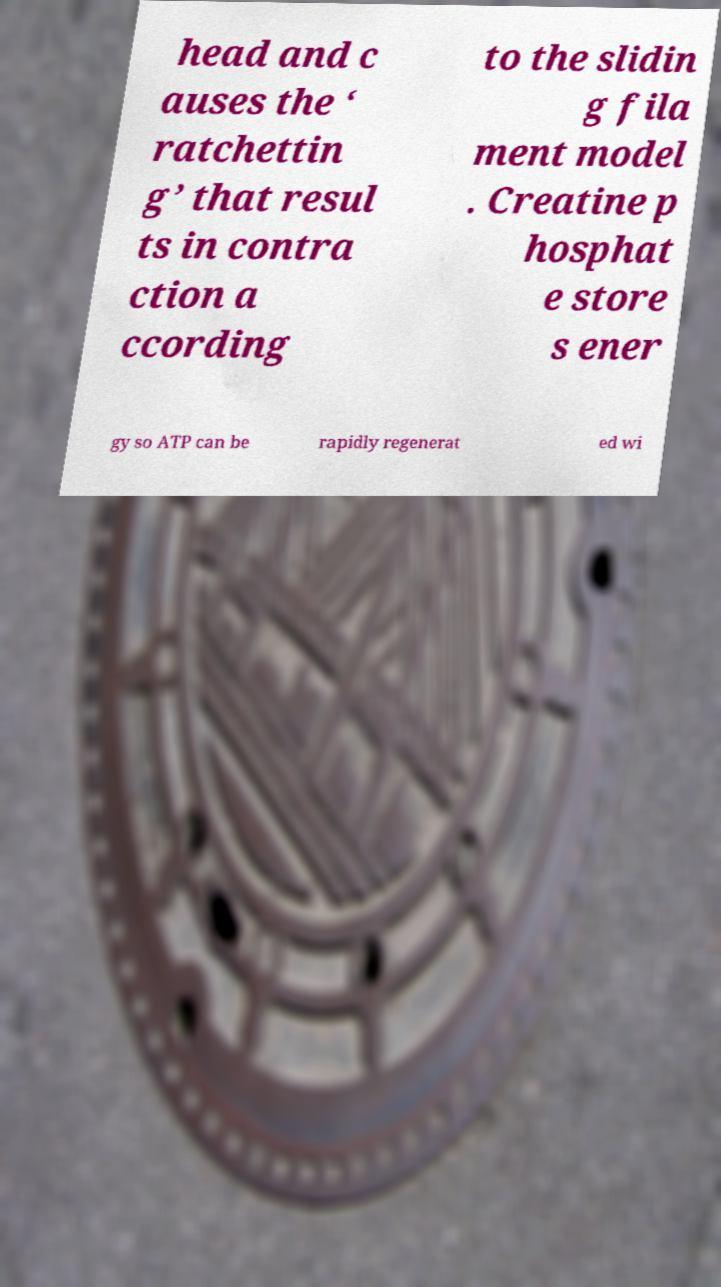Could you assist in decoding the text presented in this image and type it out clearly? head and c auses the ‘ ratchettin g’ that resul ts in contra ction a ccording to the slidin g fila ment model . Creatine p hosphat e store s ener gy so ATP can be rapidly regenerat ed wi 